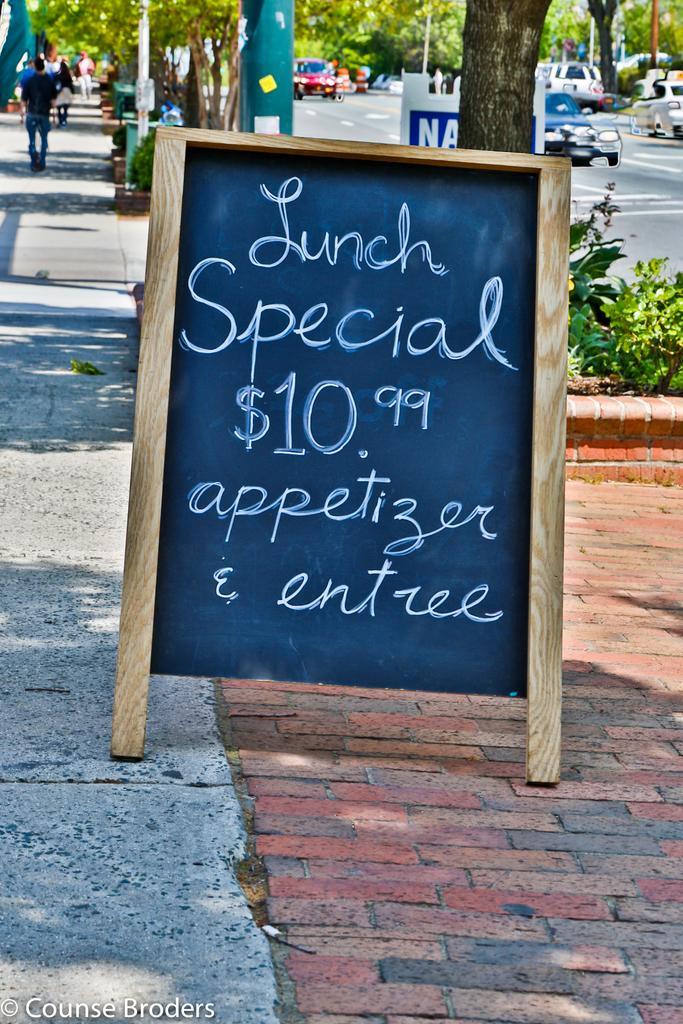How would you summarize this image in a sentence or two? This picture is clicked outside. In the center there is a board attached to the wooden stand and we can see the text is written on the board. In the foreground we can see the pavement and some plants. In the background we can see the trees, group of persons, group of vehicles, poles and some other objects. At the bottom left corner there is a text on the image. 